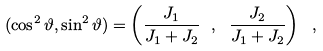<formula> <loc_0><loc_0><loc_500><loc_500>( \cos ^ { 2 } \vartheta , \sin ^ { 2 } \vartheta ) = \left ( \frac { J _ { 1 } } { J _ { 1 } + J _ { 2 } } \ , \ \frac { J _ { 2 } } { J _ { 1 } + J _ { 2 } } \right ) \ ,</formula> 